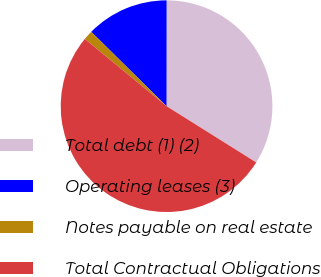Convert chart to OTSL. <chart><loc_0><loc_0><loc_500><loc_500><pie_chart><fcel>Total debt (1) (2)<fcel>Operating leases (3)<fcel>Notes payable on real estate<fcel>Total Contractual Obligations<nl><fcel>33.91%<fcel>12.61%<fcel>1.44%<fcel>52.04%<nl></chart> 